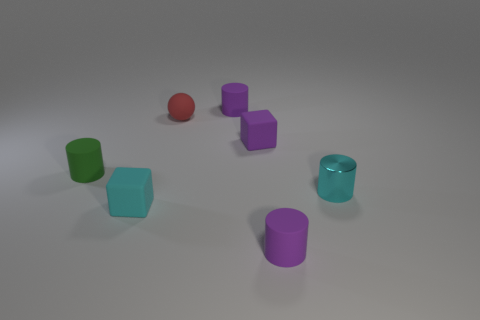Does the arrangement of objects suggest any particular pattern or relationship? While the arrangement of objects might initially seem random, a closer inspection reveals a subtle relationship between their positions. The similar objects are not clustered together but are instead evenly dispersed across the scene. This distribution could imply a deliberate design choice, aiming to create balance and harmony within the composition without an overt pattern. 